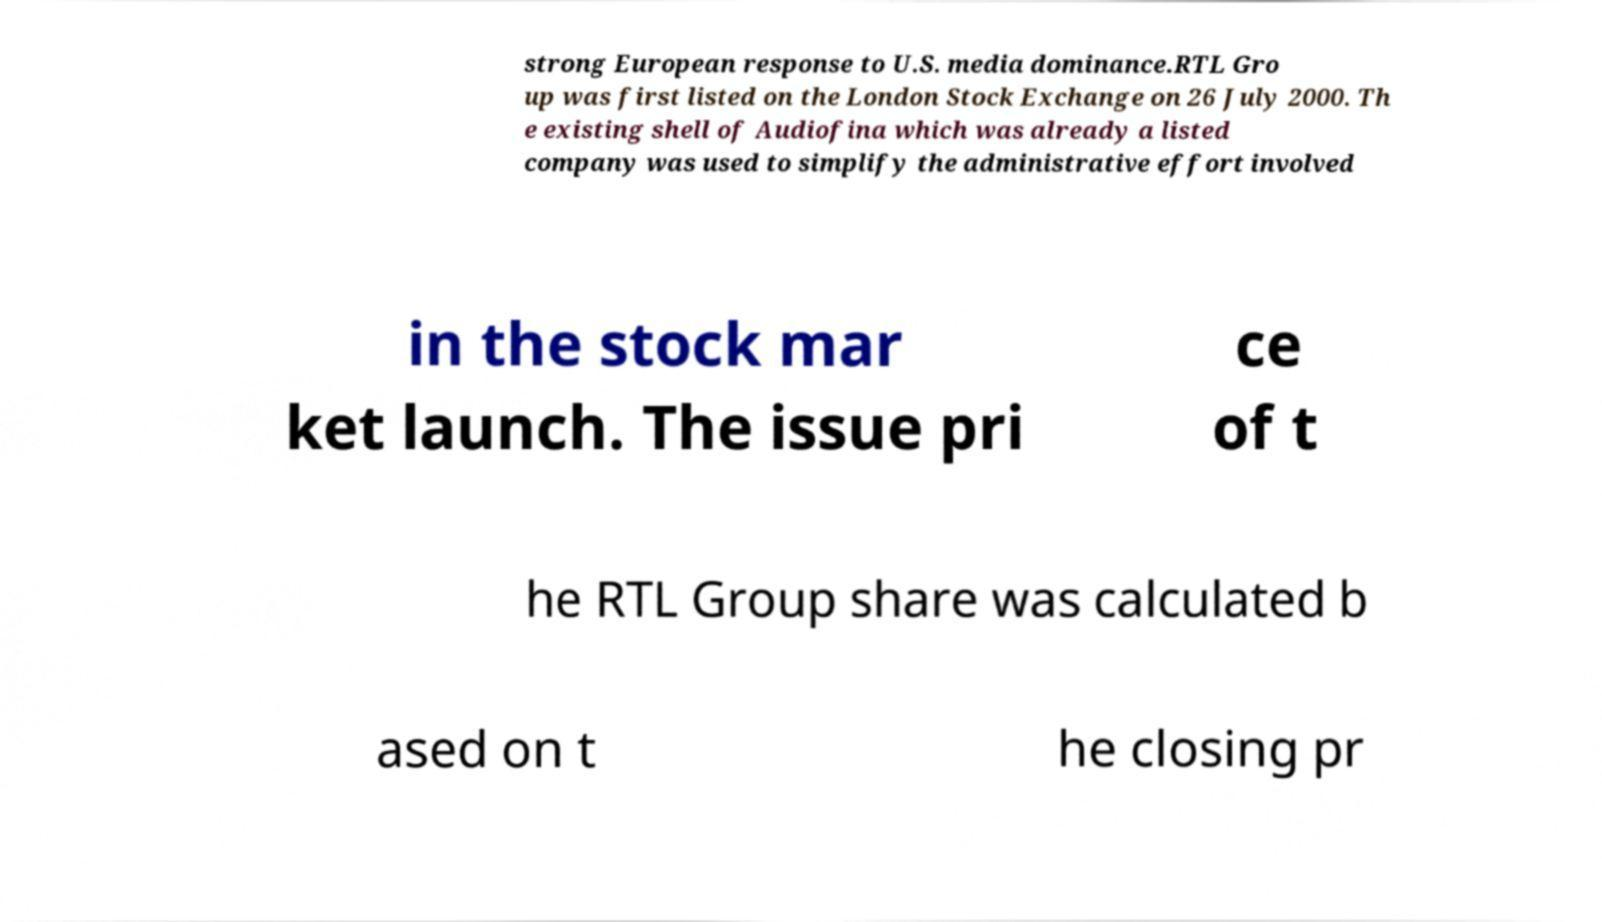I need the written content from this picture converted into text. Can you do that? strong European response to U.S. media dominance.RTL Gro up was first listed on the London Stock Exchange on 26 July 2000. Th e existing shell of Audiofina which was already a listed company was used to simplify the administrative effort involved in the stock mar ket launch. The issue pri ce of t he RTL Group share was calculated b ased on t he closing pr 